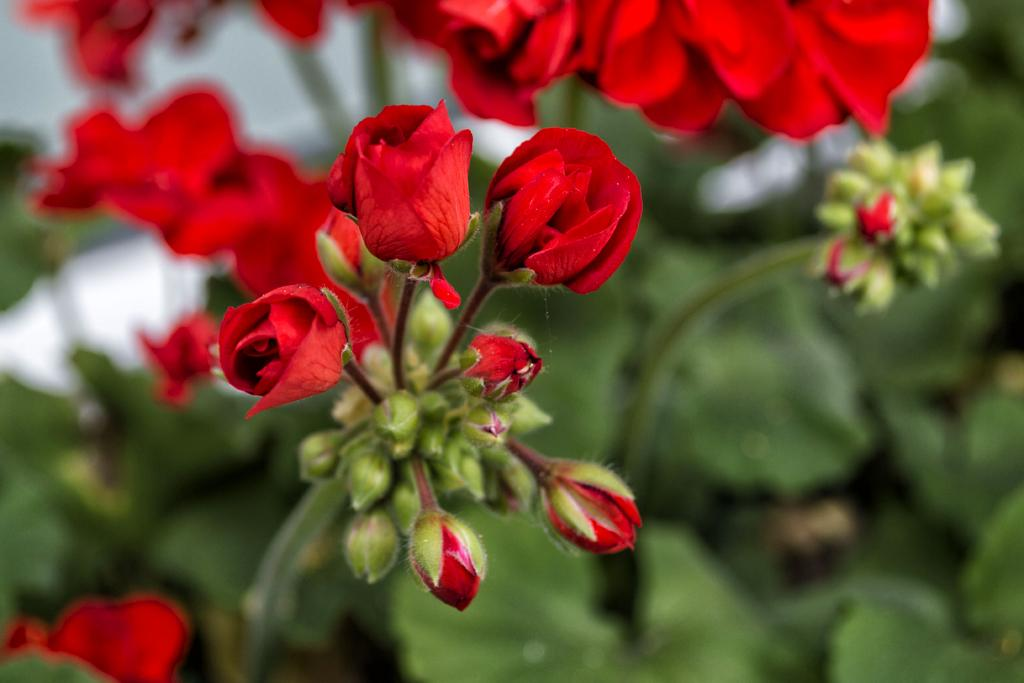What type of flowers are in the image? There are beautiful rose flowers in the image. Are there any unopened flowers in the image? Yes, there are rose buds in the image. What is the relationship between the flowers and the plant? The flowers are part of a plant. How is the background of the flowers depicted in the image? The background of the flowers is blurred. What type of stocking is visible on the rose plant in the image? There is no stocking present on the rose plant in the image. Can you tell me how many experts are examining the rose flowers in the image? There are no experts present in the image; it is a photograph of rose flowers and buds. 